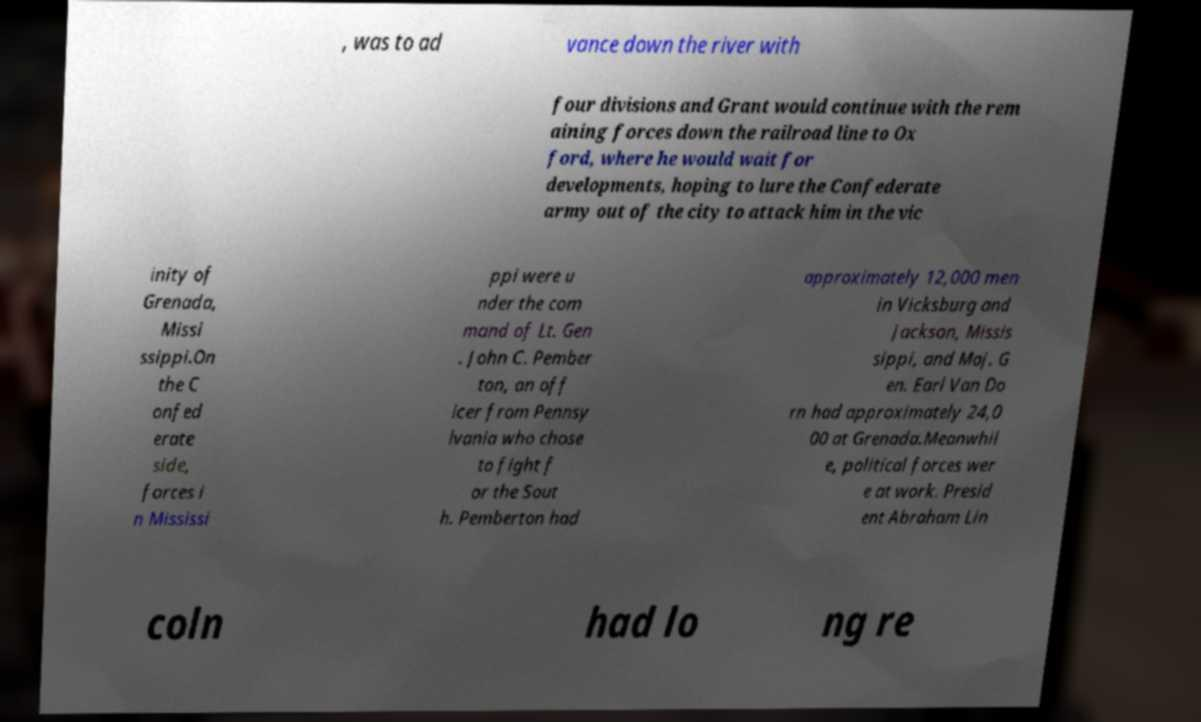What messages or text are displayed in this image? I need them in a readable, typed format. , was to ad vance down the river with four divisions and Grant would continue with the rem aining forces down the railroad line to Ox ford, where he would wait for developments, hoping to lure the Confederate army out of the city to attack him in the vic inity of Grenada, Missi ssippi.On the C onfed erate side, forces i n Mississi ppi were u nder the com mand of Lt. Gen . John C. Pember ton, an off icer from Pennsy lvania who chose to fight f or the Sout h. Pemberton had approximately 12,000 men in Vicksburg and Jackson, Missis sippi, and Maj. G en. Earl Van Do rn had approximately 24,0 00 at Grenada.Meanwhil e, political forces wer e at work. Presid ent Abraham Lin coln had lo ng re 